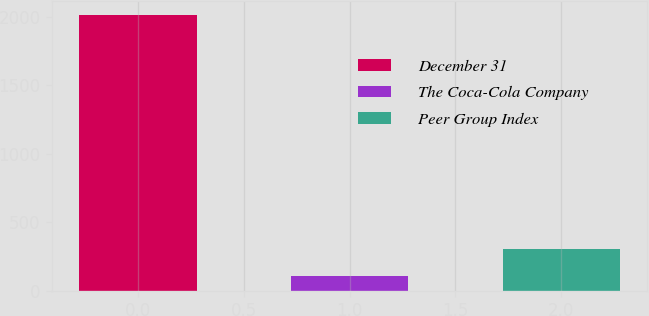Convert chart to OTSL. <chart><loc_0><loc_0><loc_500><loc_500><bar_chart><fcel>December 31<fcel>The Coca-Cola Company<fcel>Peer Group Index<nl><fcel>2015<fcel>111<fcel>301.4<nl></chart> 